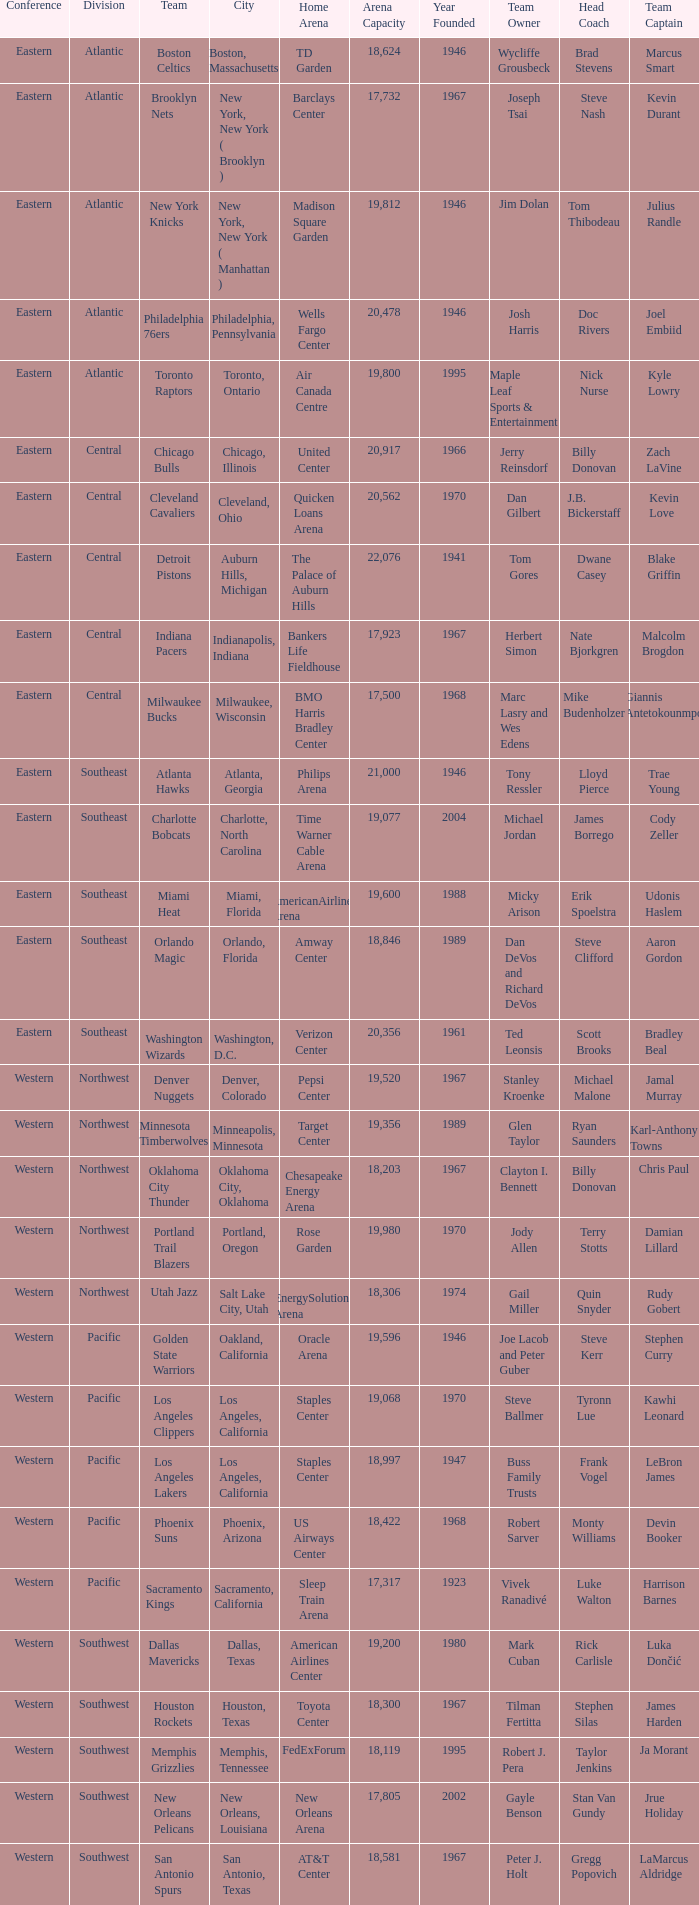Can you give me this table as a dict? {'header': ['Conference', 'Division', 'Team', 'City', 'Home Arena', 'Arena Capacity', 'Year Founded', 'Team Owner', 'Head Coach', 'Team Captain'], 'rows': [['Eastern', 'Atlantic', 'Boston Celtics', 'Boston, Massachusetts', 'TD Garden', '18,624', '1946', 'Wycliffe Grousbeck', 'Brad Stevens', 'Marcus Smart'], ['Eastern', 'Atlantic', 'Brooklyn Nets', 'New York, New York ( Brooklyn )', 'Barclays Center', '17,732', '1967', 'Joseph Tsai', 'Steve Nash', 'Kevin Durant'], ['Eastern', 'Atlantic', 'New York Knicks', 'New York, New York ( Manhattan )', 'Madison Square Garden', '19,812', '1946', 'Jim Dolan', 'Tom Thibodeau', 'Julius Randle'], ['Eastern', 'Atlantic', 'Philadelphia 76ers', 'Philadelphia, Pennsylvania', 'Wells Fargo Center', '20,478', '1946', 'Josh Harris', 'Doc Rivers', 'Joel Embiid'], ['Eastern', 'Atlantic', 'Toronto Raptors', 'Toronto, Ontario', 'Air Canada Centre', '19,800', '1995', 'Maple Leaf Sports & Entertainment', 'Nick Nurse', 'Kyle Lowry'], ['Eastern', 'Central', 'Chicago Bulls', 'Chicago, Illinois', 'United Center', '20,917', '1966', 'Jerry Reinsdorf', 'Billy Donovan', 'Zach LaVine'], ['Eastern', 'Central', 'Cleveland Cavaliers', 'Cleveland, Ohio', 'Quicken Loans Arena', '20,562', '1970', 'Dan Gilbert', 'J.B. Bickerstaff', 'Kevin Love'], ['Eastern', 'Central', 'Detroit Pistons', 'Auburn Hills, Michigan', 'The Palace of Auburn Hills', '22,076', '1941', 'Tom Gores', 'Dwane Casey', 'Blake Griffin'], ['Eastern', 'Central', 'Indiana Pacers', 'Indianapolis, Indiana', 'Bankers Life Fieldhouse', '17,923', '1967', 'Herbert Simon', 'Nate Bjorkgren', 'Malcolm Brogdon'], ['Eastern', 'Central', 'Milwaukee Bucks', 'Milwaukee, Wisconsin', 'BMO Harris Bradley Center', '17,500', '1968', 'Marc Lasry and Wes Edens', 'Mike Budenholzer', 'Giannis Antetokounmpo'], ['Eastern', 'Southeast', 'Atlanta Hawks', 'Atlanta, Georgia', 'Philips Arena', '21,000', '1946', 'Tony Ressler', 'Lloyd Pierce', 'Trae Young'], ['Eastern', 'Southeast', 'Charlotte Bobcats', 'Charlotte, North Carolina', 'Time Warner Cable Arena', '19,077', '2004', 'Michael Jordan', 'James Borrego', 'Cody Zeller'], ['Eastern', 'Southeast', 'Miami Heat', 'Miami, Florida', 'AmericanAirlines Arena', '19,600', '1988', 'Micky Arison', 'Erik Spoelstra', 'Udonis Haslem'], ['Eastern', 'Southeast', 'Orlando Magic', 'Orlando, Florida', 'Amway Center', '18,846', '1989', 'Dan DeVos and Richard DeVos', 'Steve Clifford', 'Aaron Gordon'], ['Eastern', 'Southeast', 'Washington Wizards', 'Washington, D.C.', 'Verizon Center', '20,356', '1961', 'Ted Leonsis', 'Scott Brooks', 'Bradley Beal'], ['Western', 'Northwest', 'Denver Nuggets', 'Denver, Colorado', 'Pepsi Center', '19,520', '1967', 'Stanley Kroenke', 'Michael Malone', 'Jamal Murray'], ['Western', 'Northwest', 'Minnesota Timberwolves', 'Minneapolis, Minnesota', 'Target Center', '19,356', '1989', 'Glen Taylor', 'Ryan Saunders', 'Karl-Anthony Towns'], ['Western', 'Northwest', 'Oklahoma City Thunder', 'Oklahoma City, Oklahoma', 'Chesapeake Energy Arena', '18,203', '1967', 'Clayton I. Bennett', 'Billy Donovan', 'Chris Paul'], ['Western', 'Northwest', 'Portland Trail Blazers', 'Portland, Oregon', 'Rose Garden', '19,980', '1970', 'Jody Allen', 'Terry Stotts', 'Damian Lillard'], ['Western', 'Northwest', 'Utah Jazz', 'Salt Lake City, Utah', 'EnergySolutions Arena', '18,306', '1974', 'Gail Miller', 'Quin Snyder', 'Rudy Gobert'], ['Western', 'Pacific', 'Golden State Warriors', 'Oakland, California', 'Oracle Arena', '19,596', '1946', 'Joe Lacob and Peter Guber', 'Steve Kerr', 'Stephen Curry'], ['Western', 'Pacific', 'Los Angeles Clippers', 'Los Angeles, California', 'Staples Center', '19,068', '1970', 'Steve Ballmer', 'Tyronn Lue', 'Kawhi Leonard'], ['Western', 'Pacific', 'Los Angeles Lakers', 'Los Angeles, California', 'Staples Center', '18,997', '1947', 'Buss Family Trusts', 'Frank Vogel', 'LeBron James'], ['Western', 'Pacific', 'Phoenix Suns', 'Phoenix, Arizona', 'US Airways Center', '18,422', '1968', 'Robert Sarver', 'Monty Williams', 'Devin Booker'], ['Western', 'Pacific', 'Sacramento Kings', 'Sacramento, California', 'Sleep Train Arena', '17,317', '1923', 'Vivek Ranadivé', 'Luke Walton', 'Harrison Barnes'], ['Western', 'Southwest', 'Dallas Mavericks', 'Dallas, Texas', 'American Airlines Center', '19,200', '1980', 'Mark Cuban', 'Rick Carlisle', 'Luka Dončić'], ['Western', 'Southwest', 'Houston Rockets', 'Houston, Texas', 'Toyota Center', '18,300', '1967', 'Tilman Fertitta', 'Stephen Silas', 'James Harden'], ['Western', 'Southwest', 'Memphis Grizzlies', 'Memphis, Tennessee', 'FedExForum', '18,119', '1995', 'Robert J. Pera', 'Taylor Jenkins', 'Ja Morant'], ['Western', 'Southwest', 'New Orleans Pelicans', 'New Orleans, Louisiana', 'New Orleans Arena', '17,805', '2002', 'Gayle Benson', 'Stan Van Gundy', 'Jrue Holiday'], ['Western', 'Southwest', 'San Antonio Spurs', 'San Antonio, Texas', 'AT&T Center', '18,581', '1967', 'Peter J. Holt', 'Gregg Popovich', 'LaMarcus Aldridge']]} Which division do the Toronto Raptors belong in? Atlantic. 